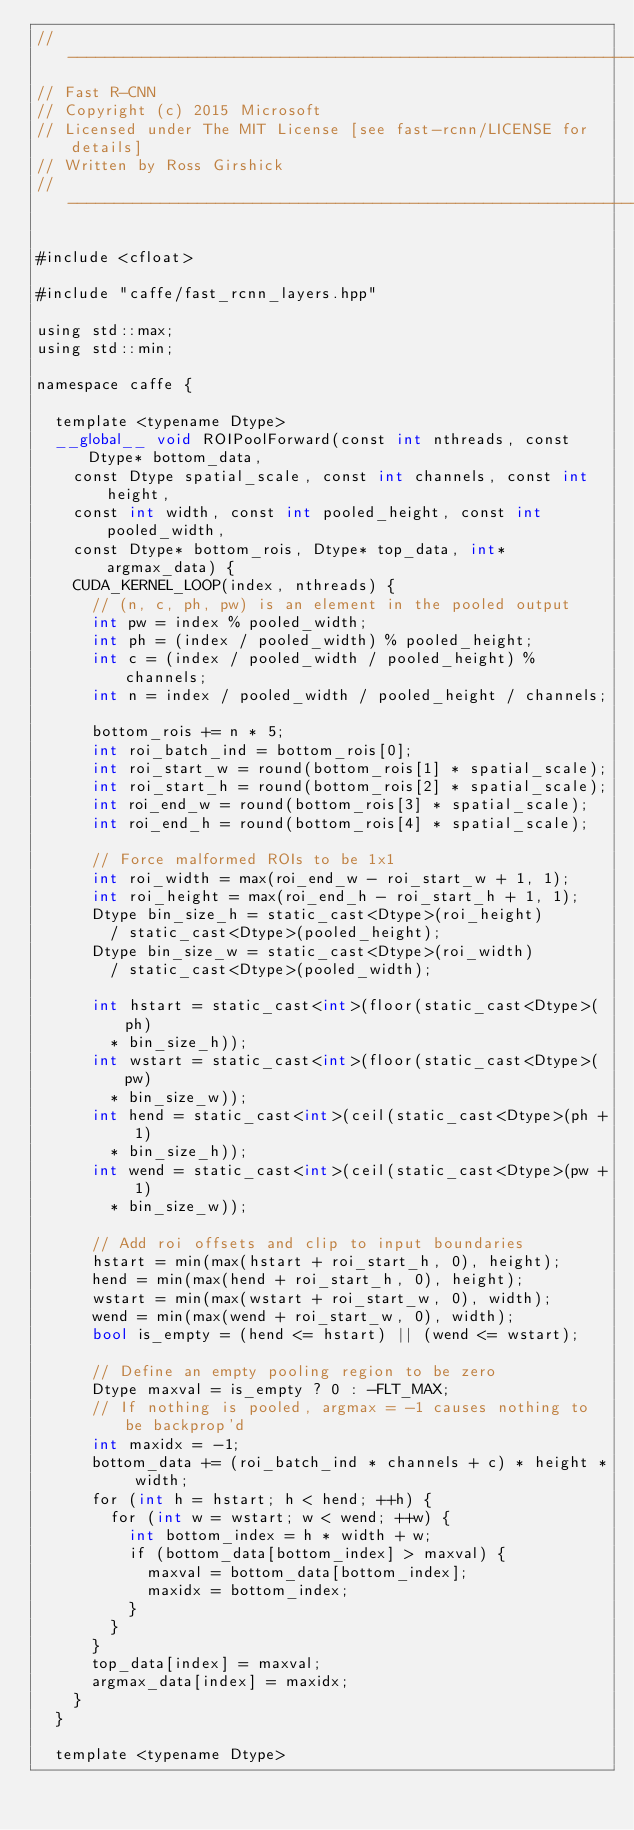<code> <loc_0><loc_0><loc_500><loc_500><_Cuda_>// ------------------------------------------------------------------
// Fast R-CNN
// Copyright (c) 2015 Microsoft
// Licensed under The MIT License [see fast-rcnn/LICENSE for details]
// Written by Ross Girshick
// ------------------------------------------------------------------

#include <cfloat>

#include "caffe/fast_rcnn_layers.hpp"

using std::max;
using std::min;

namespace caffe {

  template <typename Dtype>
  __global__ void ROIPoolForward(const int nthreads, const Dtype* bottom_data,
    const Dtype spatial_scale, const int channels, const int height,
    const int width, const int pooled_height, const int pooled_width,
    const Dtype* bottom_rois, Dtype* top_data, int* argmax_data) {
    CUDA_KERNEL_LOOP(index, nthreads) {
      // (n, c, ph, pw) is an element in the pooled output
      int pw = index % pooled_width;
      int ph = (index / pooled_width) % pooled_height;
      int c = (index / pooled_width / pooled_height) % channels;
      int n = index / pooled_width / pooled_height / channels;

      bottom_rois += n * 5;
      int roi_batch_ind = bottom_rois[0];
      int roi_start_w = round(bottom_rois[1] * spatial_scale);
      int roi_start_h = round(bottom_rois[2] * spatial_scale);
      int roi_end_w = round(bottom_rois[3] * spatial_scale);
      int roi_end_h = round(bottom_rois[4] * spatial_scale);

      // Force malformed ROIs to be 1x1
      int roi_width = max(roi_end_w - roi_start_w + 1, 1);
      int roi_height = max(roi_end_h - roi_start_h + 1, 1);
      Dtype bin_size_h = static_cast<Dtype>(roi_height)
        / static_cast<Dtype>(pooled_height);
      Dtype bin_size_w = static_cast<Dtype>(roi_width)
        / static_cast<Dtype>(pooled_width);

      int hstart = static_cast<int>(floor(static_cast<Dtype>(ph)
        * bin_size_h));
      int wstart = static_cast<int>(floor(static_cast<Dtype>(pw)
        * bin_size_w));
      int hend = static_cast<int>(ceil(static_cast<Dtype>(ph + 1)
        * bin_size_h));
      int wend = static_cast<int>(ceil(static_cast<Dtype>(pw + 1)
        * bin_size_w));

      // Add roi offsets and clip to input boundaries
      hstart = min(max(hstart + roi_start_h, 0), height);
      hend = min(max(hend + roi_start_h, 0), height);
      wstart = min(max(wstart + roi_start_w, 0), width);
      wend = min(max(wend + roi_start_w, 0), width);
      bool is_empty = (hend <= hstart) || (wend <= wstart);

      // Define an empty pooling region to be zero
      Dtype maxval = is_empty ? 0 : -FLT_MAX;
      // If nothing is pooled, argmax = -1 causes nothing to be backprop'd
      int maxidx = -1;
      bottom_data += (roi_batch_ind * channels + c) * height * width;
      for (int h = hstart; h < hend; ++h) {
        for (int w = wstart; w < wend; ++w) {
          int bottom_index = h * width + w;
          if (bottom_data[bottom_index] > maxval) {
            maxval = bottom_data[bottom_index];
            maxidx = bottom_index;
          }
        }
      }
      top_data[index] = maxval;
      argmax_data[index] = maxidx;
    }
  }

  template <typename Dtype></code> 